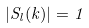Convert formula to latex. <formula><loc_0><loc_0><loc_500><loc_500>| S _ { l } ( k ) | = 1</formula> 